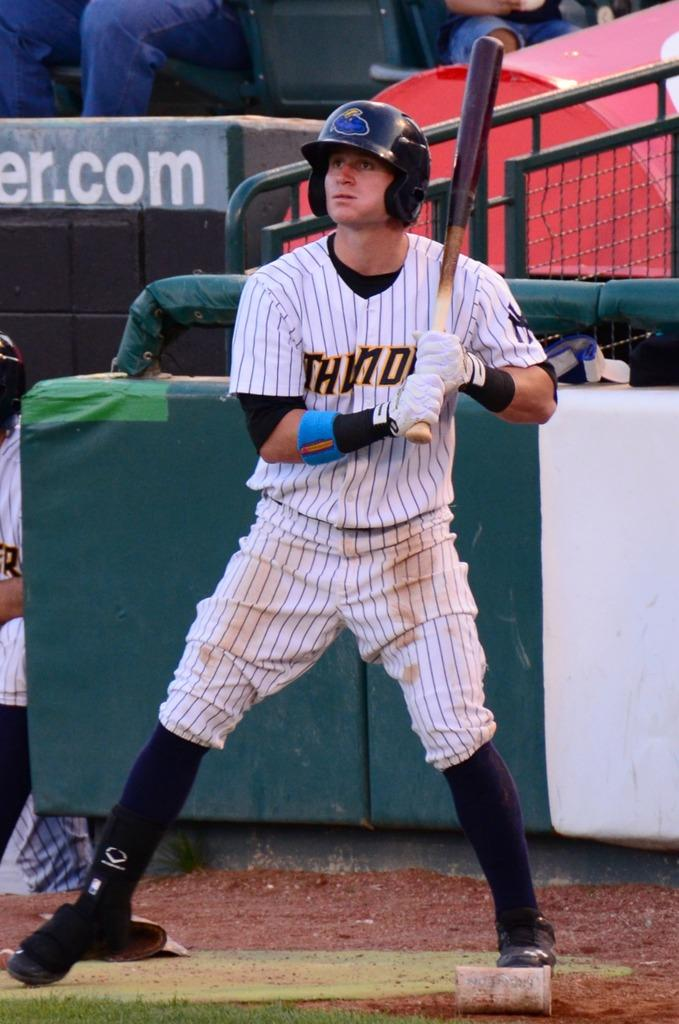Provide a one-sentence caption for the provided image. A man wearing a Thunder uniform holds a baseball bat. 